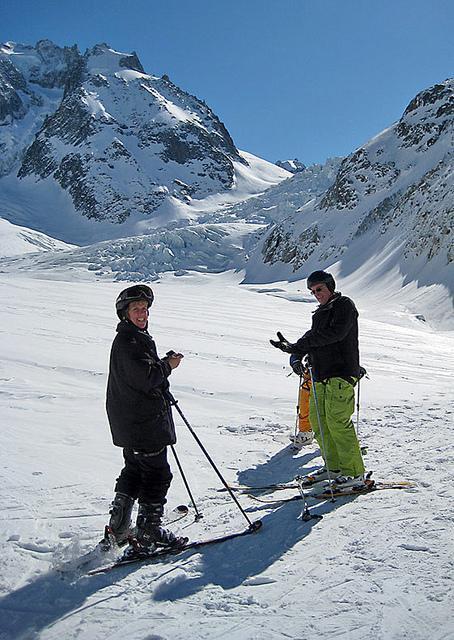How many people in the photo?
Give a very brief answer. 2. How many ski are visible?
Give a very brief answer. 1. 